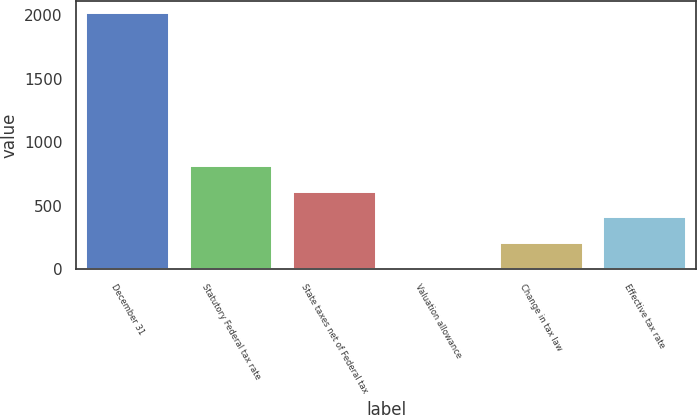Convert chart to OTSL. <chart><loc_0><loc_0><loc_500><loc_500><bar_chart><fcel>December 31<fcel>Statutory Federal tax rate<fcel>State taxes net of Federal tax<fcel>Valuation allowance<fcel>Change in tax law<fcel>Effective tax rate<nl><fcel>2016<fcel>812.4<fcel>611.8<fcel>10<fcel>210.6<fcel>411.2<nl></chart> 